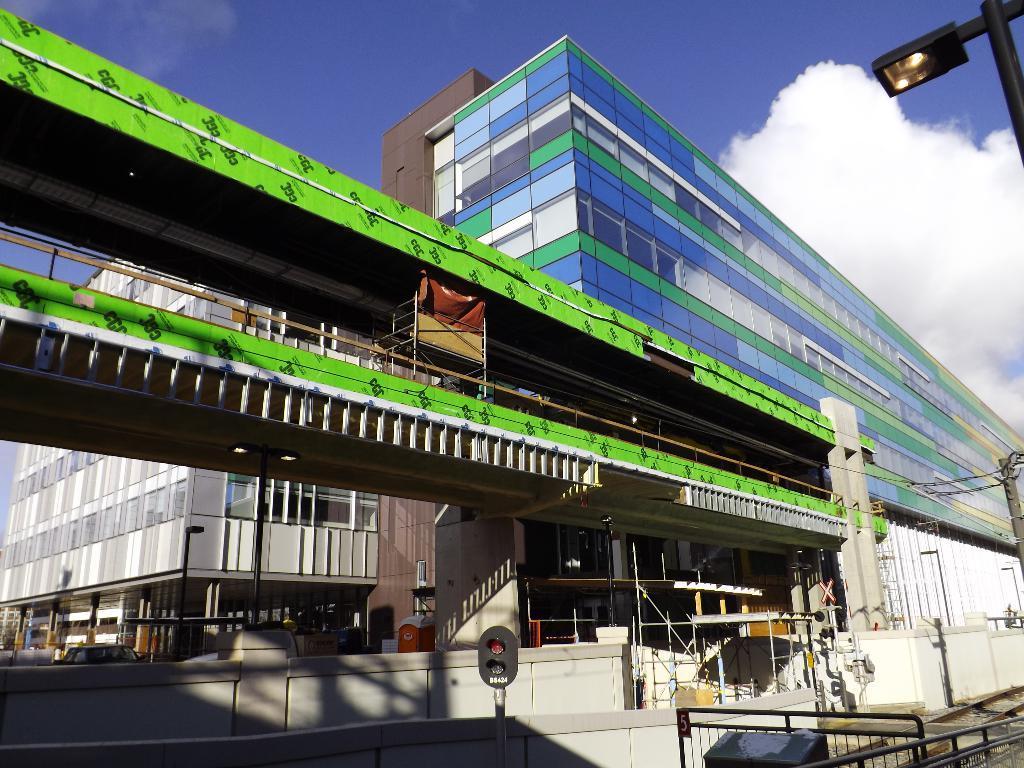How would you summarize this image in a sentence or two? Here we can see buildings and there is a light. In the background there is sky with clouds. 